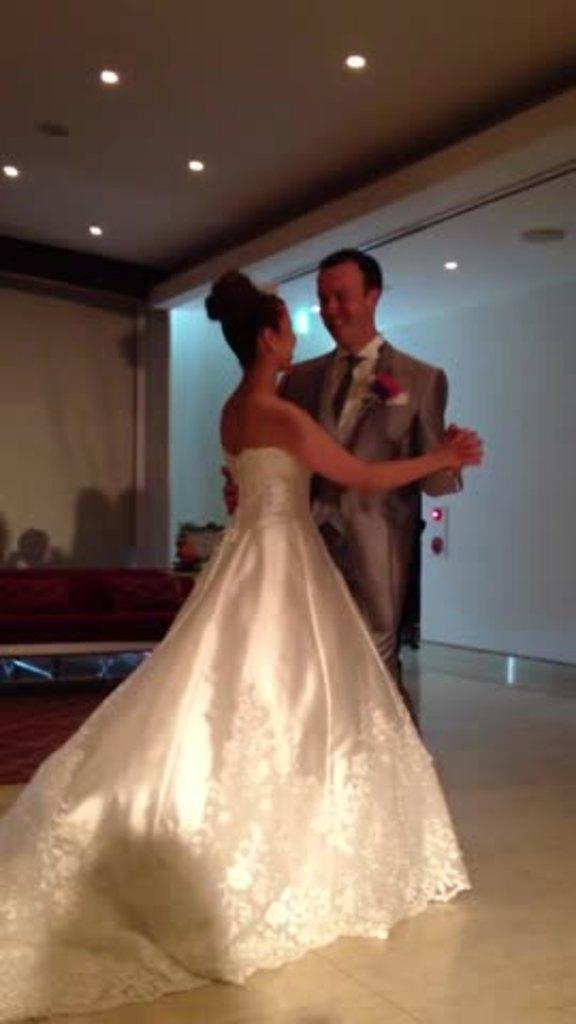How would you summarize this image in a sentence or two? In this picture we can see there are two people dancing on the floor and behind the people there is a wall and some objects. At the top there are ceiling lights. 